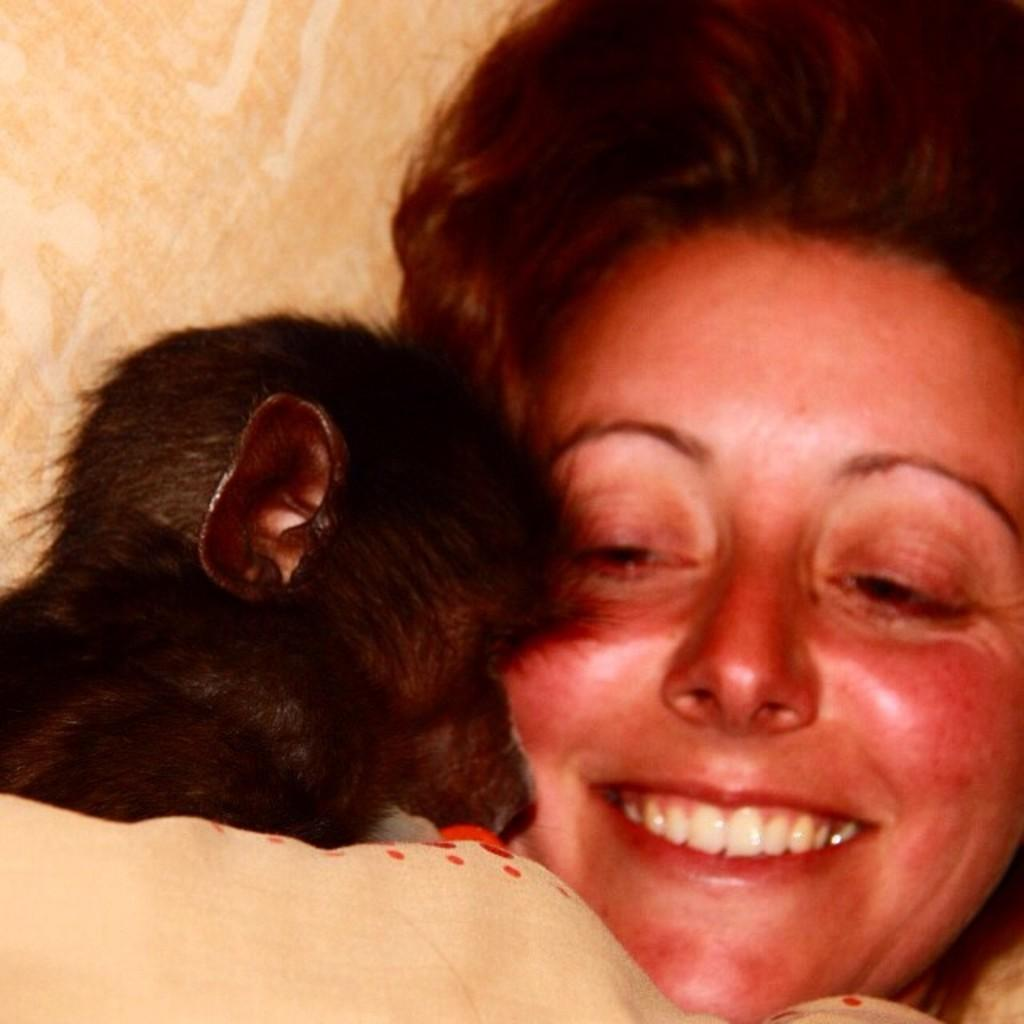Who is present in the image? There is a woman in the image. Where is the woman located in the image? The woman is on the right side of the image. What expression does the woman have? The woman is smiling. What type of animal can be seen in the image? There is a black color animal in the image. Where is the animal located in the image? The animal is on the left side of the image. What type of advertisement can be seen in the image? There is no advertisement present in the image. What type of seed is growing on the left side of the image? There is no seed or plant visible in the image; it only features a woman and a black color animal. 